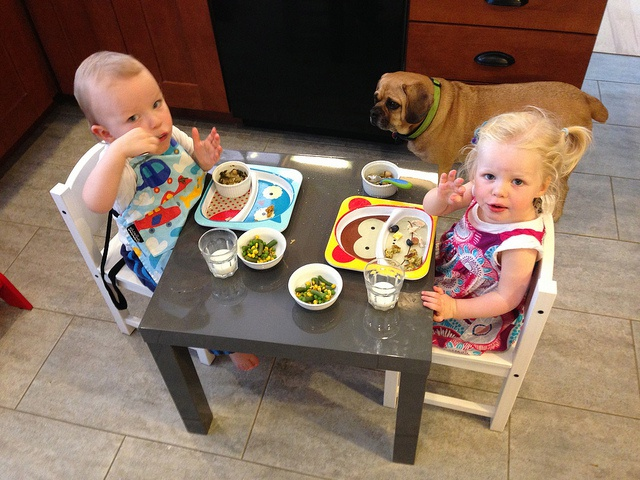Describe the objects in this image and their specific colors. I can see dining table in maroon, gray, black, and ivory tones, people in maroon, salmon, tan, lightgray, and brown tones, people in maroon, salmon, tan, and darkgray tones, dog in maroon, brown, tan, and black tones, and chair in maroon, tan, and beige tones in this image. 